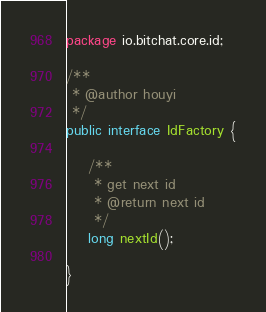Convert code to text. <code><loc_0><loc_0><loc_500><loc_500><_Java_>package io.bitchat.core.id;

/**
 * @author houyi
 */
public interface IdFactory {

    /**
     * get next id
     * @return next id
     */
    long nextId();

}
</code> 